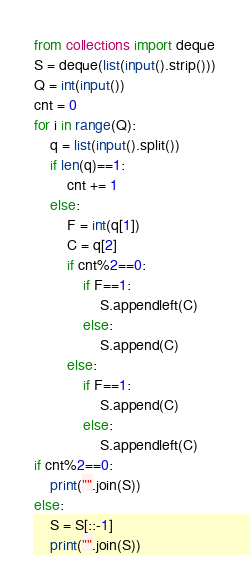<code> <loc_0><loc_0><loc_500><loc_500><_Python_>from collections import deque
S = deque(list(input().strip()))
Q = int(input())
cnt = 0
for i in range(Q):
    q = list(input().split())
    if len(q)==1:
        cnt += 1
    else:
        F = int(q[1])
        C = q[2]
        if cnt%2==0:
            if F==1:
                S.appendleft(C)
            else:
                S.append(C)
        else:
            if F==1:
                S.append(C)
            else:
                S.appendleft(C)
if cnt%2==0:
    print("".join(S))
else:
    S = S[::-1]
    print("".join(S))</code> 